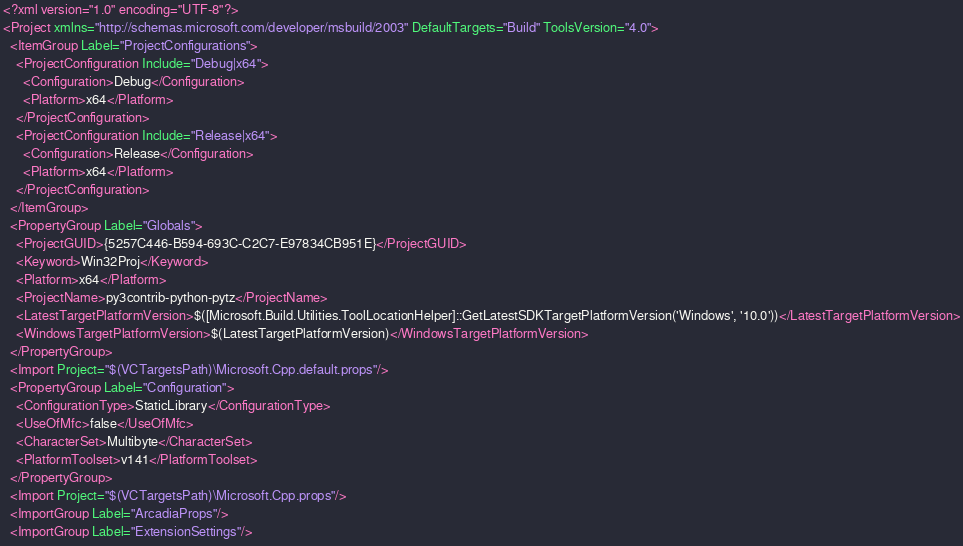<code> <loc_0><loc_0><loc_500><loc_500><_XML_><?xml version="1.0" encoding="UTF-8"?>
<Project xmlns="http://schemas.microsoft.com/developer/msbuild/2003" DefaultTargets="Build" ToolsVersion="4.0">
  <ItemGroup Label="ProjectConfigurations">
    <ProjectConfiguration Include="Debug|x64">
      <Configuration>Debug</Configuration>
      <Platform>x64</Platform>
    </ProjectConfiguration>
    <ProjectConfiguration Include="Release|x64">
      <Configuration>Release</Configuration>
      <Platform>x64</Platform>
    </ProjectConfiguration>
  </ItemGroup>
  <PropertyGroup Label="Globals">
    <ProjectGUID>{5257C446-B594-693C-C2C7-E97834CB951E}</ProjectGUID>
    <Keyword>Win32Proj</Keyword>
    <Platform>x64</Platform>
    <ProjectName>py3contrib-python-pytz</ProjectName>
    <LatestTargetPlatformVersion>$([Microsoft.Build.Utilities.ToolLocationHelper]::GetLatestSDKTargetPlatformVersion('Windows', '10.0'))</LatestTargetPlatformVersion>
    <WindowsTargetPlatformVersion>$(LatestTargetPlatformVersion)</WindowsTargetPlatformVersion>
  </PropertyGroup>
  <Import Project="$(VCTargetsPath)\Microsoft.Cpp.default.props"/>
  <PropertyGroup Label="Configuration">
    <ConfigurationType>StaticLibrary</ConfigurationType>
    <UseOfMfc>false</UseOfMfc>
    <CharacterSet>Multibyte</CharacterSet>
    <PlatformToolset>v141</PlatformToolset>
  </PropertyGroup>
  <Import Project="$(VCTargetsPath)\Microsoft.Cpp.props"/>
  <ImportGroup Label="ArcadiaProps"/>
  <ImportGroup Label="ExtensionSettings"/></code> 